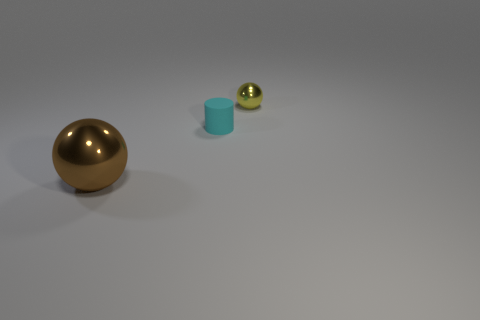What is the shape of the brown metal thing? The brown object appears to be a sphere, which is a perfectly round geometrical object in three-dimensional space, similar to the shape of a ball. 